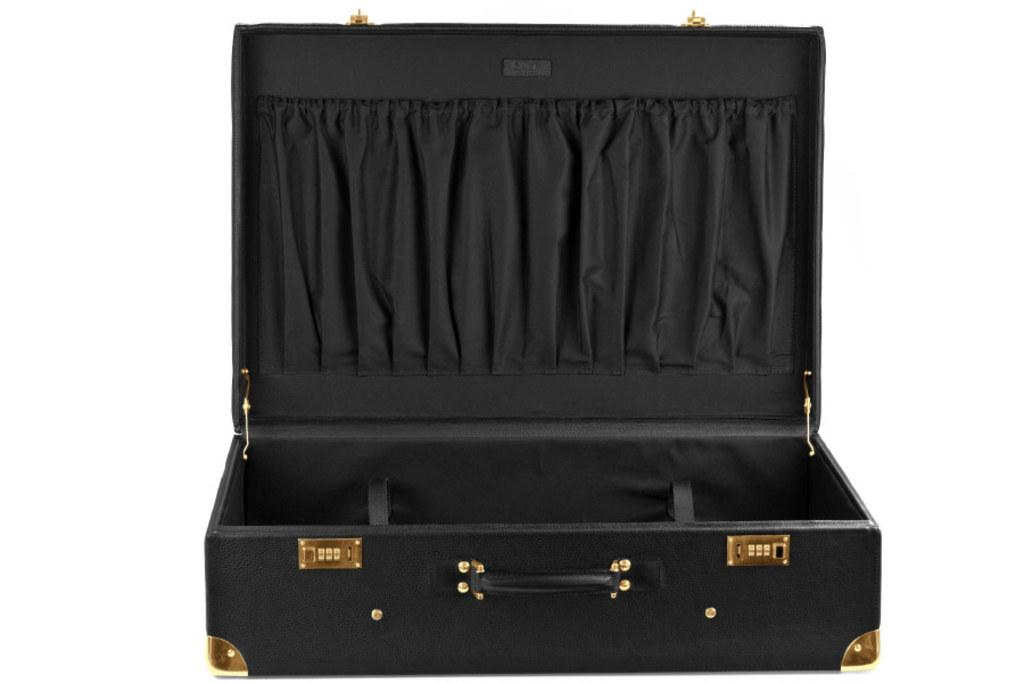What object can be seen in the image that is commonly used for carrying documents or personal belongings? There is a briefcase in the image. What is the current state of the briefcase in the image? The briefcase is opened. What feature of the briefcase is mentioned in the facts? The briefcase has a locker system. What type of jelly can be seen inside the briefcase in the image? There is no jelly present inside the briefcase in the image. What thought is being expressed by the person holding the briefcase in the image? There is no person holding the briefcase in the image, so it is impossible to determine their thoughts. 